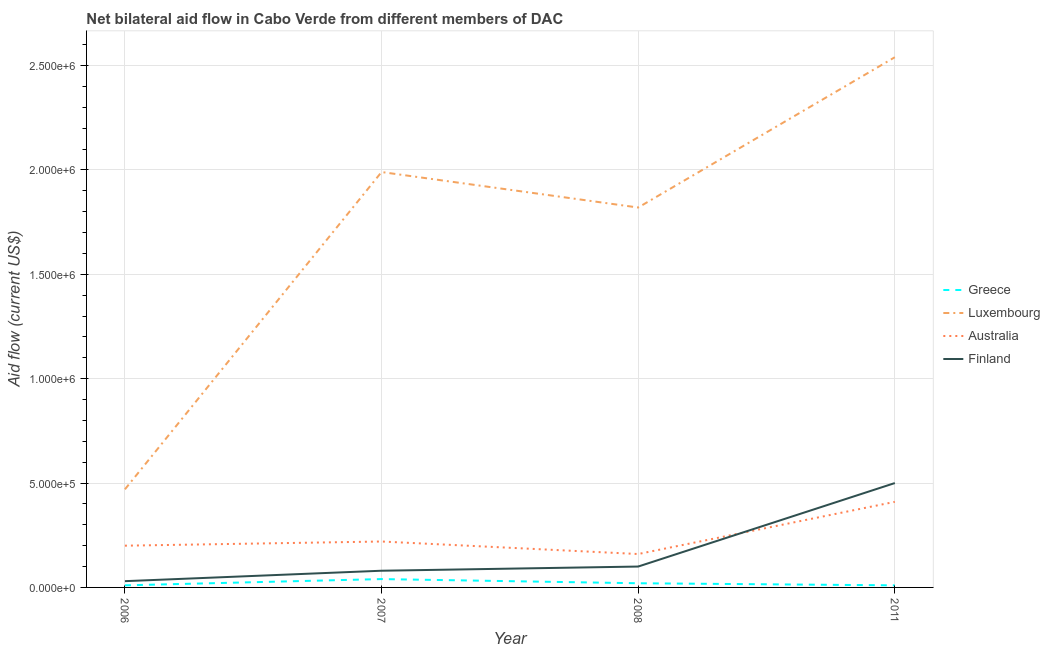Is the number of lines equal to the number of legend labels?
Your answer should be very brief. Yes. What is the amount of aid given by australia in 2008?
Your response must be concise. 1.60e+05. Across all years, what is the maximum amount of aid given by greece?
Your answer should be compact. 4.00e+04. Across all years, what is the minimum amount of aid given by greece?
Provide a short and direct response. 10000. In which year was the amount of aid given by luxembourg maximum?
Give a very brief answer. 2011. What is the total amount of aid given by australia in the graph?
Provide a succinct answer. 9.90e+05. What is the difference between the amount of aid given by greece in 2006 and that in 2007?
Give a very brief answer. -3.00e+04. What is the difference between the amount of aid given by finland in 2011 and the amount of aid given by australia in 2006?
Keep it short and to the point. 3.00e+05. What is the average amount of aid given by greece per year?
Offer a terse response. 2.00e+04. In the year 2006, what is the difference between the amount of aid given by australia and amount of aid given by greece?
Provide a short and direct response. 1.90e+05. What is the ratio of the amount of aid given by luxembourg in 2006 to that in 2011?
Your response must be concise. 0.19. Is the amount of aid given by finland in 2006 less than that in 2011?
Your response must be concise. Yes. What is the difference between the highest and the lowest amount of aid given by finland?
Provide a succinct answer. 4.70e+05. In how many years, is the amount of aid given by greece greater than the average amount of aid given by greece taken over all years?
Your answer should be very brief. 1. Is it the case that in every year, the sum of the amount of aid given by finland and amount of aid given by luxembourg is greater than the sum of amount of aid given by greece and amount of aid given by australia?
Provide a short and direct response. No. Does the amount of aid given by finland monotonically increase over the years?
Your response must be concise. Yes. Is the amount of aid given by luxembourg strictly greater than the amount of aid given by finland over the years?
Make the answer very short. Yes. How many years are there in the graph?
Offer a terse response. 4. Does the graph contain any zero values?
Give a very brief answer. No. Where does the legend appear in the graph?
Your answer should be compact. Center right. How many legend labels are there?
Give a very brief answer. 4. What is the title of the graph?
Provide a short and direct response. Net bilateral aid flow in Cabo Verde from different members of DAC. What is the label or title of the X-axis?
Give a very brief answer. Year. What is the Aid flow (current US$) of Luxembourg in 2007?
Offer a terse response. 1.99e+06. What is the Aid flow (current US$) in Australia in 2007?
Make the answer very short. 2.20e+05. What is the Aid flow (current US$) of Finland in 2007?
Keep it short and to the point. 8.00e+04. What is the Aid flow (current US$) in Luxembourg in 2008?
Provide a succinct answer. 1.82e+06. What is the Aid flow (current US$) of Finland in 2008?
Provide a short and direct response. 1.00e+05. What is the Aid flow (current US$) in Luxembourg in 2011?
Offer a terse response. 2.54e+06. What is the Aid flow (current US$) of Australia in 2011?
Ensure brevity in your answer.  4.10e+05. Across all years, what is the maximum Aid flow (current US$) in Luxembourg?
Provide a succinct answer. 2.54e+06. Across all years, what is the minimum Aid flow (current US$) of Greece?
Your response must be concise. 10000. Across all years, what is the minimum Aid flow (current US$) in Luxembourg?
Give a very brief answer. 4.70e+05. Across all years, what is the minimum Aid flow (current US$) in Australia?
Give a very brief answer. 1.60e+05. What is the total Aid flow (current US$) in Luxembourg in the graph?
Your response must be concise. 6.82e+06. What is the total Aid flow (current US$) in Australia in the graph?
Offer a terse response. 9.90e+05. What is the total Aid flow (current US$) in Finland in the graph?
Your response must be concise. 7.10e+05. What is the difference between the Aid flow (current US$) of Luxembourg in 2006 and that in 2007?
Provide a short and direct response. -1.52e+06. What is the difference between the Aid flow (current US$) of Australia in 2006 and that in 2007?
Give a very brief answer. -2.00e+04. What is the difference between the Aid flow (current US$) of Greece in 2006 and that in 2008?
Your answer should be compact. -10000. What is the difference between the Aid flow (current US$) in Luxembourg in 2006 and that in 2008?
Your response must be concise. -1.35e+06. What is the difference between the Aid flow (current US$) in Australia in 2006 and that in 2008?
Offer a terse response. 4.00e+04. What is the difference between the Aid flow (current US$) in Finland in 2006 and that in 2008?
Give a very brief answer. -7.00e+04. What is the difference between the Aid flow (current US$) of Greece in 2006 and that in 2011?
Provide a succinct answer. 0. What is the difference between the Aid flow (current US$) of Luxembourg in 2006 and that in 2011?
Keep it short and to the point. -2.07e+06. What is the difference between the Aid flow (current US$) in Australia in 2006 and that in 2011?
Make the answer very short. -2.10e+05. What is the difference between the Aid flow (current US$) in Finland in 2006 and that in 2011?
Offer a very short reply. -4.70e+05. What is the difference between the Aid flow (current US$) in Luxembourg in 2007 and that in 2011?
Provide a succinct answer. -5.50e+05. What is the difference between the Aid flow (current US$) of Finland in 2007 and that in 2011?
Provide a succinct answer. -4.20e+05. What is the difference between the Aid flow (current US$) of Luxembourg in 2008 and that in 2011?
Your answer should be compact. -7.20e+05. What is the difference between the Aid flow (current US$) in Finland in 2008 and that in 2011?
Your response must be concise. -4.00e+05. What is the difference between the Aid flow (current US$) of Greece in 2006 and the Aid flow (current US$) of Luxembourg in 2007?
Your answer should be very brief. -1.98e+06. What is the difference between the Aid flow (current US$) of Luxembourg in 2006 and the Aid flow (current US$) of Australia in 2007?
Offer a very short reply. 2.50e+05. What is the difference between the Aid flow (current US$) in Greece in 2006 and the Aid flow (current US$) in Luxembourg in 2008?
Your response must be concise. -1.81e+06. What is the difference between the Aid flow (current US$) in Greece in 2006 and the Aid flow (current US$) in Australia in 2008?
Your response must be concise. -1.50e+05. What is the difference between the Aid flow (current US$) in Greece in 2006 and the Aid flow (current US$) in Finland in 2008?
Offer a very short reply. -9.00e+04. What is the difference between the Aid flow (current US$) of Luxembourg in 2006 and the Aid flow (current US$) of Australia in 2008?
Make the answer very short. 3.10e+05. What is the difference between the Aid flow (current US$) in Luxembourg in 2006 and the Aid flow (current US$) in Finland in 2008?
Make the answer very short. 3.70e+05. What is the difference between the Aid flow (current US$) in Greece in 2006 and the Aid flow (current US$) in Luxembourg in 2011?
Make the answer very short. -2.53e+06. What is the difference between the Aid flow (current US$) in Greece in 2006 and the Aid flow (current US$) in Australia in 2011?
Offer a very short reply. -4.00e+05. What is the difference between the Aid flow (current US$) of Greece in 2006 and the Aid flow (current US$) of Finland in 2011?
Offer a terse response. -4.90e+05. What is the difference between the Aid flow (current US$) in Greece in 2007 and the Aid flow (current US$) in Luxembourg in 2008?
Give a very brief answer. -1.78e+06. What is the difference between the Aid flow (current US$) in Greece in 2007 and the Aid flow (current US$) in Finland in 2008?
Give a very brief answer. -6.00e+04. What is the difference between the Aid flow (current US$) of Luxembourg in 2007 and the Aid flow (current US$) of Australia in 2008?
Give a very brief answer. 1.83e+06. What is the difference between the Aid flow (current US$) of Luxembourg in 2007 and the Aid flow (current US$) of Finland in 2008?
Your answer should be very brief. 1.89e+06. What is the difference between the Aid flow (current US$) of Greece in 2007 and the Aid flow (current US$) of Luxembourg in 2011?
Make the answer very short. -2.50e+06. What is the difference between the Aid flow (current US$) in Greece in 2007 and the Aid flow (current US$) in Australia in 2011?
Make the answer very short. -3.70e+05. What is the difference between the Aid flow (current US$) in Greece in 2007 and the Aid flow (current US$) in Finland in 2011?
Provide a short and direct response. -4.60e+05. What is the difference between the Aid flow (current US$) of Luxembourg in 2007 and the Aid flow (current US$) of Australia in 2011?
Your response must be concise. 1.58e+06. What is the difference between the Aid flow (current US$) in Luxembourg in 2007 and the Aid flow (current US$) in Finland in 2011?
Make the answer very short. 1.49e+06. What is the difference between the Aid flow (current US$) in Australia in 2007 and the Aid flow (current US$) in Finland in 2011?
Offer a very short reply. -2.80e+05. What is the difference between the Aid flow (current US$) in Greece in 2008 and the Aid flow (current US$) in Luxembourg in 2011?
Offer a terse response. -2.52e+06. What is the difference between the Aid flow (current US$) of Greece in 2008 and the Aid flow (current US$) of Australia in 2011?
Your response must be concise. -3.90e+05. What is the difference between the Aid flow (current US$) in Greece in 2008 and the Aid flow (current US$) in Finland in 2011?
Keep it short and to the point. -4.80e+05. What is the difference between the Aid flow (current US$) in Luxembourg in 2008 and the Aid flow (current US$) in Australia in 2011?
Your answer should be compact. 1.41e+06. What is the difference between the Aid flow (current US$) of Luxembourg in 2008 and the Aid flow (current US$) of Finland in 2011?
Your response must be concise. 1.32e+06. What is the difference between the Aid flow (current US$) in Australia in 2008 and the Aid flow (current US$) in Finland in 2011?
Provide a short and direct response. -3.40e+05. What is the average Aid flow (current US$) in Greece per year?
Your answer should be compact. 2.00e+04. What is the average Aid flow (current US$) of Luxembourg per year?
Offer a very short reply. 1.70e+06. What is the average Aid flow (current US$) of Australia per year?
Keep it short and to the point. 2.48e+05. What is the average Aid flow (current US$) in Finland per year?
Your response must be concise. 1.78e+05. In the year 2006, what is the difference between the Aid flow (current US$) in Greece and Aid flow (current US$) in Luxembourg?
Keep it short and to the point. -4.60e+05. In the year 2006, what is the difference between the Aid flow (current US$) in Greece and Aid flow (current US$) in Finland?
Provide a succinct answer. -2.00e+04. In the year 2006, what is the difference between the Aid flow (current US$) of Luxembourg and Aid flow (current US$) of Australia?
Keep it short and to the point. 2.70e+05. In the year 2006, what is the difference between the Aid flow (current US$) in Australia and Aid flow (current US$) in Finland?
Keep it short and to the point. 1.70e+05. In the year 2007, what is the difference between the Aid flow (current US$) of Greece and Aid flow (current US$) of Luxembourg?
Provide a short and direct response. -1.95e+06. In the year 2007, what is the difference between the Aid flow (current US$) of Greece and Aid flow (current US$) of Australia?
Provide a short and direct response. -1.80e+05. In the year 2007, what is the difference between the Aid flow (current US$) in Luxembourg and Aid flow (current US$) in Australia?
Ensure brevity in your answer.  1.77e+06. In the year 2007, what is the difference between the Aid flow (current US$) in Luxembourg and Aid flow (current US$) in Finland?
Provide a short and direct response. 1.91e+06. In the year 2008, what is the difference between the Aid flow (current US$) in Greece and Aid flow (current US$) in Luxembourg?
Provide a short and direct response. -1.80e+06. In the year 2008, what is the difference between the Aid flow (current US$) of Greece and Aid flow (current US$) of Australia?
Your answer should be compact. -1.40e+05. In the year 2008, what is the difference between the Aid flow (current US$) of Greece and Aid flow (current US$) of Finland?
Keep it short and to the point. -8.00e+04. In the year 2008, what is the difference between the Aid flow (current US$) of Luxembourg and Aid flow (current US$) of Australia?
Offer a very short reply. 1.66e+06. In the year 2008, what is the difference between the Aid flow (current US$) of Luxembourg and Aid flow (current US$) of Finland?
Ensure brevity in your answer.  1.72e+06. In the year 2011, what is the difference between the Aid flow (current US$) of Greece and Aid flow (current US$) of Luxembourg?
Your response must be concise. -2.53e+06. In the year 2011, what is the difference between the Aid flow (current US$) in Greece and Aid flow (current US$) in Australia?
Give a very brief answer. -4.00e+05. In the year 2011, what is the difference between the Aid flow (current US$) of Greece and Aid flow (current US$) of Finland?
Your response must be concise. -4.90e+05. In the year 2011, what is the difference between the Aid flow (current US$) of Luxembourg and Aid flow (current US$) of Australia?
Your response must be concise. 2.13e+06. In the year 2011, what is the difference between the Aid flow (current US$) of Luxembourg and Aid flow (current US$) of Finland?
Your answer should be compact. 2.04e+06. In the year 2011, what is the difference between the Aid flow (current US$) of Australia and Aid flow (current US$) of Finland?
Keep it short and to the point. -9.00e+04. What is the ratio of the Aid flow (current US$) in Greece in 2006 to that in 2007?
Provide a succinct answer. 0.25. What is the ratio of the Aid flow (current US$) in Luxembourg in 2006 to that in 2007?
Offer a terse response. 0.24. What is the ratio of the Aid flow (current US$) of Australia in 2006 to that in 2007?
Your response must be concise. 0.91. What is the ratio of the Aid flow (current US$) in Finland in 2006 to that in 2007?
Your answer should be compact. 0.38. What is the ratio of the Aid flow (current US$) of Greece in 2006 to that in 2008?
Provide a short and direct response. 0.5. What is the ratio of the Aid flow (current US$) of Luxembourg in 2006 to that in 2008?
Your response must be concise. 0.26. What is the ratio of the Aid flow (current US$) of Australia in 2006 to that in 2008?
Your response must be concise. 1.25. What is the ratio of the Aid flow (current US$) of Greece in 2006 to that in 2011?
Your answer should be compact. 1. What is the ratio of the Aid flow (current US$) in Luxembourg in 2006 to that in 2011?
Offer a very short reply. 0.18. What is the ratio of the Aid flow (current US$) of Australia in 2006 to that in 2011?
Your answer should be compact. 0.49. What is the ratio of the Aid flow (current US$) in Luxembourg in 2007 to that in 2008?
Give a very brief answer. 1.09. What is the ratio of the Aid flow (current US$) in Australia in 2007 to that in 2008?
Ensure brevity in your answer.  1.38. What is the ratio of the Aid flow (current US$) of Finland in 2007 to that in 2008?
Provide a short and direct response. 0.8. What is the ratio of the Aid flow (current US$) of Luxembourg in 2007 to that in 2011?
Give a very brief answer. 0.78. What is the ratio of the Aid flow (current US$) in Australia in 2007 to that in 2011?
Your response must be concise. 0.54. What is the ratio of the Aid flow (current US$) in Finland in 2007 to that in 2011?
Ensure brevity in your answer.  0.16. What is the ratio of the Aid flow (current US$) of Greece in 2008 to that in 2011?
Give a very brief answer. 2. What is the ratio of the Aid flow (current US$) of Luxembourg in 2008 to that in 2011?
Keep it short and to the point. 0.72. What is the ratio of the Aid flow (current US$) of Australia in 2008 to that in 2011?
Make the answer very short. 0.39. What is the difference between the highest and the second highest Aid flow (current US$) of Greece?
Offer a terse response. 2.00e+04. What is the difference between the highest and the second highest Aid flow (current US$) in Finland?
Offer a very short reply. 4.00e+05. What is the difference between the highest and the lowest Aid flow (current US$) of Luxembourg?
Offer a terse response. 2.07e+06. What is the difference between the highest and the lowest Aid flow (current US$) of Australia?
Your answer should be very brief. 2.50e+05. What is the difference between the highest and the lowest Aid flow (current US$) of Finland?
Make the answer very short. 4.70e+05. 